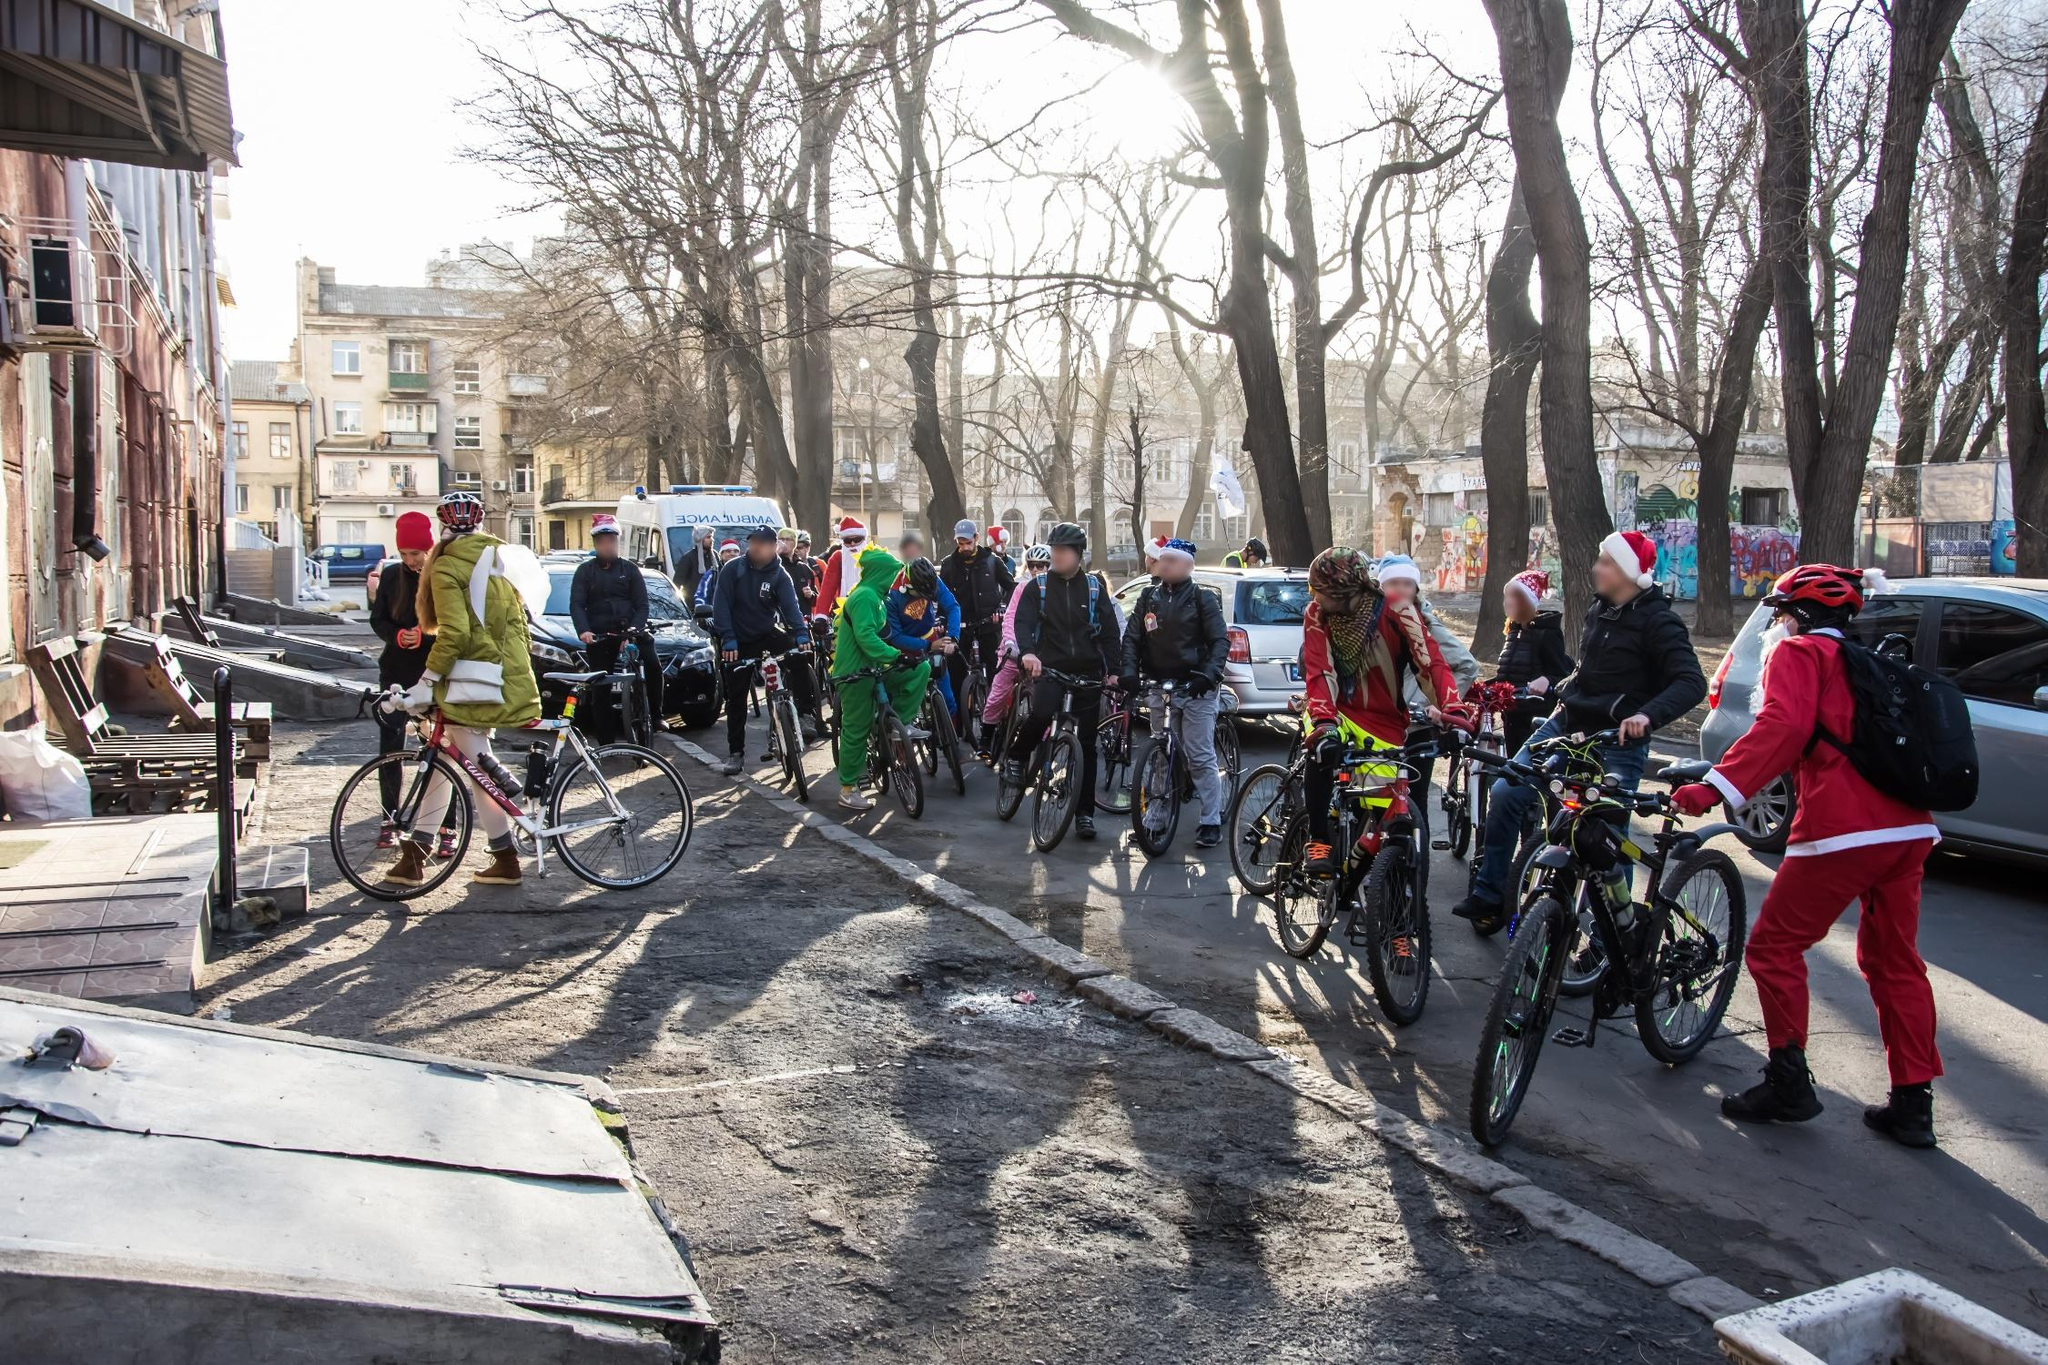Can you create a future scenario where this event has become a major city tradition? In the future, this festive cycling event has evolved into a major city tradition known as the 'Yuletide Cycle Parade'. Each year, thousands of participants from all corners of the city and beyond gather, adding to the vibrant tapestry of the event. The city streets are closed to traffic, turning into a cycle-friendly, festive domain for the day. Elaborate decorations line the route, with local businesses and residents competing in a friendly contest for the best costume and float. The news and social media are abuzz with coverage, capturing the smiling faces, colorful costumes, and creative floats. The city’s mayor, now the grand marshal of the parade, leads the procession, dressed in festive attire. The event not only promotes joy and community spirit but also raises significant funds for local charities. The Yuletide Cycle Parade has become a hallmark of the city's holiday season, a beacon of unity, joy, and festive spirit that residents eagerly anticipate year after year. 